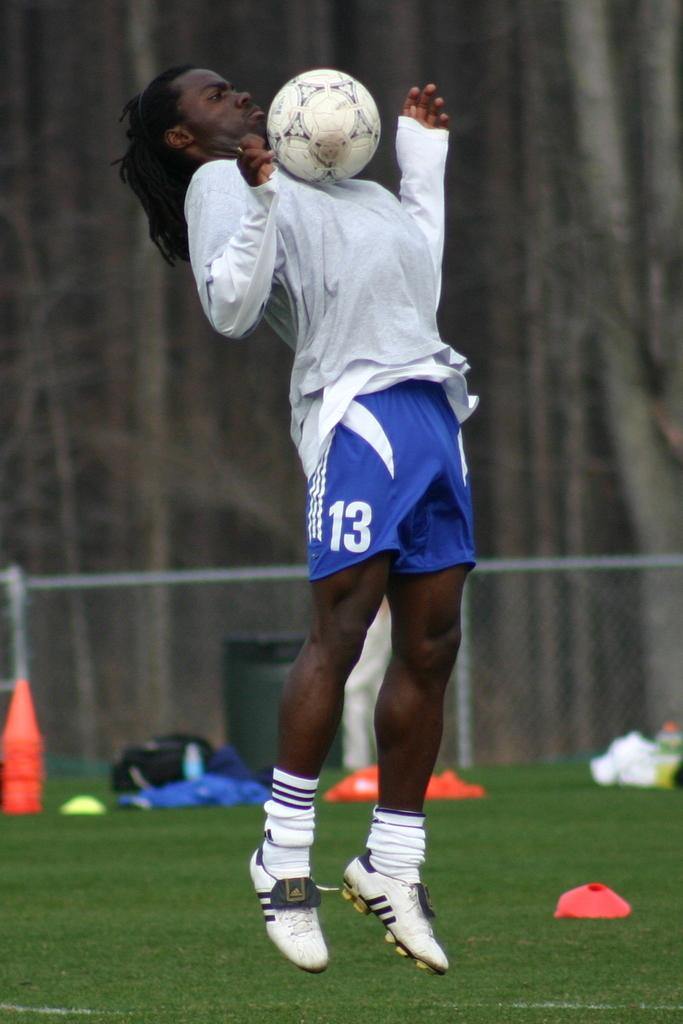What is present in the image? There is a man and a ball in the image. Can you describe the man in the image? The facts provided do not give any specific details about the man. What is the ball's color or size in the image? The facts provided do not give any specific details about the ball. What type of beef is the man eating in the image? There is no indication in the image that the man is eating beef or any other food. What is the man's annual income in the image? There is no information about the man's income in the image. 